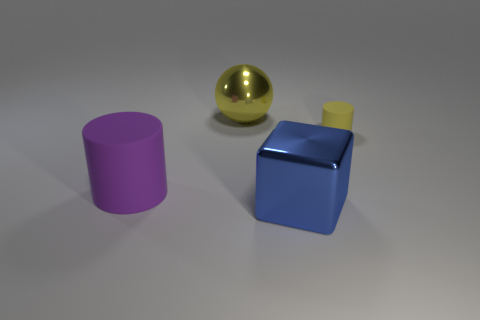Add 4 purple rubber blocks. How many objects exist? 8 Subtract all cubes. How many objects are left? 3 Add 3 gray rubber balls. How many gray rubber balls exist? 3 Subtract 1 blue cubes. How many objects are left? 3 Subtract all small cyan cylinders. Subtract all large blue things. How many objects are left? 3 Add 2 large purple things. How many large purple things are left? 3 